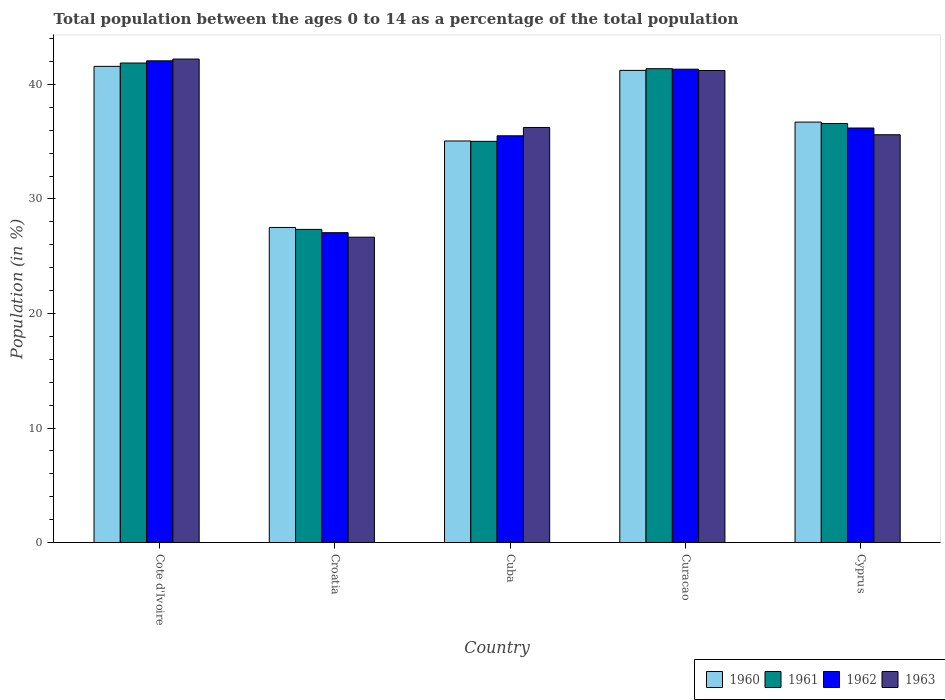How many groups of bars are there?
Your answer should be compact. 5. Are the number of bars per tick equal to the number of legend labels?
Keep it short and to the point. Yes. Are the number of bars on each tick of the X-axis equal?
Provide a succinct answer. Yes. How many bars are there on the 2nd tick from the left?
Your answer should be very brief. 4. What is the label of the 2nd group of bars from the left?
Offer a very short reply. Croatia. What is the percentage of the population ages 0 to 14 in 1963 in Cyprus?
Provide a short and direct response. 35.6. Across all countries, what is the maximum percentage of the population ages 0 to 14 in 1961?
Ensure brevity in your answer.  41.86. Across all countries, what is the minimum percentage of the population ages 0 to 14 in 1960?
Your response must be concise. 27.51. In which country was the percentage of the population ages 0 to 14 in 1961 maximum?
Provide a succinct answer. Cote d'Ivoire. In which country was the percentage of the population ages 0 to 14 in 1960 minimum?
Your answer should be compact. Croatia. What is the total percentage of the population ages 0 to 14 in 1961 in the graph?
Provide a succinct answer. 182.19. What is the difference between the percentage of the population ages 0 to 14 in 1961 in Croatia and that in Curacao?
Keep it short and to the point. -14.03. What is the difference between the percentage of the population ages 0 to 14 in 1962 in Croatia and the percentage of the population ages 0 to 14 in 1960 in Cote d'Ivoire?
Offer a very short reply. -14.52. What is the average percentage of the population ages 0 to 14 in 1960 per country?
Make the answer very short. 36.41. What is the difference between the percentage of the population ages 0 to 14 of/in 1963 and percentage of the population ages 0 to 14 of/in 1962 in Cyprus?
Keep it short and to the point. -0.59. What is the ratio of the percentage of the population ages 0 to 14 in 1962 in Croatia to that in Cyprus?
Your response must be concise. 0.75. Is the percentage of the population ages 0 to 14 in 1961 in Croatia less than that in Curacao?
Offer a terse response. Yes. What is the difference between the highest and the second highest percentage of the population ages 0 to 14 in 1962?
Offer a very short reply. -0.73. What is the difference between the highest and the lowest percentage of the population ages 0 to 14 in 1962?
Your response must be concise. 15. Is the sum of the percentage of the population ages 0 to 14 in 1963 in Curacao and Cyprus greater than the maximum percentage of the population ages 0 to 14 in 1962 across all countries?
Make the answer very short. Yes. Is it the case that in every country, the sum of the percentage of the population ages 0 to 14 in 1961 and percentage of the population ages 0 to 14 in 1960 is greater than the sum of percentage of the population ages 0 to 14 in 1962 and percentage of the population ages 0 to 14 in 1963?
Offer a very short reply. No. Is it the case that in every country, the sum of the percentage of the population ages 0 to 14 in 1963 and percentage of the population ages 0 to 14 in 1961 is greater than the percentage of the population ages 0 to 14 in 1962?
Your answer should be very brief. Yes. How many countries are there in the graph?
Offer a terse response. 5. What is the difference between two consecutive major ticks on the Y-axis?
Ensure brevity in your answer.  10. Are the values on the major ticks of Y-axis written in scientific E-notation?
Keep it short and to the point. No. Does the graph contain any zero values?
Keep it short and to the point. No. Does the graph contain grids?
Make the answer very short. No. How many legend labels are there?
Make the answer very short. 4. How are the legend labels stacked?
Give a very brief answer. Horizontal. What is the title of the graph?
Offer a terse response. Total population between the ages 0 to 14 as a percentage of the total population. What is the label or title of the X-axis?
Ensure brevity in your answer.  Country. What is the label or title of the Y-axis?
Offer a very short reply. Population (in %). What is the Population (in %) in 1960 in Cote d'Ivoire?
Give a very brief answer. 41.57. What is the Population (in %) in 1961 in Cote d'Ivoire?
Keep it short and to the point. 41.86. What is the Population (in %) of 1962 in Cote d'Ivoire?
Provide a succinct answer. 42.06. What is the Population (in %) in 1963 in Cote d'Ivoire?
Offer a terse response. 42.21. What is the Population (in %) in 1960 in Croatia?
Keep it short and to the point. 27.51. What is the Population (in %) of 1961 in Croatia?
Offer a terse response. 27.34. What is the Population (in %) of 1962 in Croatia?
Offer a terse response. 27.05. What is the Population (in %) in 1963 in Croatia?
Offer a very short reply. 26.66. What is the Population (in %) of 1960 in Cuba?
Provide a succinct answer. 35.06. What is the Population (in %) in 1961 in Cuba?
Offer a very short reply. 35.03. What is the Population (in %) in 1962 in Cuba?
Provide a succinct answer. 35.51. What is the Population (in %) in 1963 in Cuba?
Offer a very short reply. 36.24. What is the Population (in %) in 1960 in Curacao?
Keep it short and to the point. 41.22. What is the Population (in %) in 1961 in Curacao?
Your response must be concise. 41.37. What is the Population (in %) of 1962 in Curacao?
Your answer should be compact. 41.33. What is the Population (in %) in 1963 in Curacao?
Keep it short and to the point. 41.21. What is the Population (in %) of 1960 in Cyprus?
Offer a very short reply. 36.71. What is the Population (in %) of 1961 in Cyprus?
Ensure brevity in your answer.  36.59. What is the Population (in %) in 1962 in Cyprus?
Offer a very short reply. 36.19. What is the Population (in %) of 1963 in Cyprus?
Ensure brevity in your answer.  35.6. Across all countries, what is the maximum Population (in %) in 1960?
Provide a succinct answer. 41.57. Across all countries, what is the maximum Population (in %) in 1961?
Keep it short and to the point. 41.86. Across all countries, what is the maximum Population (in %) of 1962?
Provide a succinct answer. 42.06. Across all countries, what is the maximum Population (in %) in 1963?
Ensure brevity in your answer.  42.21. Across all countries, what is the minimum Population (in %) in 1960?
Provide a short and direct response. 27.51. Across all countries, what is the minimum Population (in %) of 1961?
Provide a succinct answer. 27.34. Across all countries, what is the minimum Population (in %) of 1962?
Provide a succinct answer. 27.05. Across all countries, what is the minimum Population (in %) of 1963?
Provide a succinct answer. 26.66. What is the total Population (in %) of 1960 in the graph?
Your answer should be compact. 182.07. What is the total Population (in %) in 1961 in the graph?
Your answer should be compact. 182.19. What is the total Population (in %) in 1962 in the graph?
Offer a very short reply. 182.14. What is the total Population (in %) of 1963 in the graph?
Your answer should be compact. 181.93. What is the difference between the Population (in %) in 1960 in Cote d'Ivoire and that in Croatia?
Offer a very short reply. 14.06. What is the difference between the Population (in %) of 1961 in Cote d'Ivoire and that in Croatia?
Your answer should be compact. 14.52. What is the difference between the Population (in %) of 1962 in Cote d'Ivoire and that in Croatia?
Give a very brief answer. 15. What is the difference between the Population (in %) in 1963 in Cote d'Ivoire and that in Croatia?
Your answer should be compact. 15.55. What is the difference between the Population (in %) of 1960 in Cote d'Ivoire and that in Cuba?
Give a very brief answer. 6.51. What is the difference between the Population (in %) of 1961 in Cote d'Ivoire and that in Cuba?
Provide a short and direct response. 6.84. What is the difference between the Population (in %) of 1962 in Cote d'Ivoire and that in Cuba?
Ensure brevity in your answer.  6.54. What is the difference between the Population (in %) in 1963 in Cote d'Ivoire and that in Cuba?
Offer a very short reply. 5.97. What is the difference between the Population (in %) in 1960 in Cote d'Ivoire and that in Curacao?
Keep it short and to the point. 0.35. What is the difference between the Population (in %) of 1961 in Cote d'Ivoire and that in Curacao?
Your answer should be compact. 0.49. What is the difference between the Population (in %) of 1962 in Cote d'Ivoire and that in Curacao?
Keep it short and to the point. 0.73. What is the difference between the Population (in %) of 1960 in Cote d'Ivoire and that in Cyprus?
Make the answer very short. 4.87. What is the difference between the Population (in %) of 1961 in Cote d'Ivoire and that in Cyprus?
Offer a very short reply. 5.28. What is the difference between the Population (in %) of 1962 in Cote d'Ivoire and that in Cyprus?
Make the answer very short. 5.87. What is the difference between the Population (in %) in 1963 in Cote d'Ivoire and that in Cyprus?
Your answer should be very brief. 6.61. What is the difference between the Population (in %) of 1960 in Croatia and that in Cuba?
Provide a short and direct response. -7.55. What is the difference between the Population (in %) of 1961 in Croatia and that in Cuba?
Provide a succinct answer. -7.69. What is the difference between the Population (in %) in 1962 in Croatia and that in Cuba?
Your answer should be compact. -8.46. What is the difference between the Population (in %) of 1963 in Croatia and that in Cuba?
Offer a very short reply. -9.58. What is the difference between the Population (in %) in 1960 in Croatia and that in Curacao?
Offer a terse response. -13.71. What is the difference between the Population (in %) in 1961 in Croatia and that in Curacao?
Your answer should be compact. -14.03. What is the difference between the Population (in %) in 1962 in Croatia and that in Curacao?
Give a very brief answer. -14.27. What is the difference between the Population (in %) of 1963 in Croatia and that in Curacao?
Offer a terse response. -14.55. What is the difference between the Population (in %) of 1960 in Croatia and that in Cyprus?
Your response must be concise. -9.2. What is the difference between the Population (in %) in 1961 in Croatia and that in Cyprus?
Your response must be concise. -9.25. What is the difference between the Population (in %) in 1962 in Croatia and that in Cyprus?
Ensure brevity in your answer.  -9.14. What is the difference between the Population (in %) of 1963 in Croatia and that in Cyprus?
Offer a terse response. -8.94. What is the difference between the Population (in %) of 1960 in Cuba and that in Curacao?
Provide a succinct answer. -6.16. What is the difference between the Population (in %) of 1961 in Cuba and that in Curacao?
Provide a short and direct response. -6.34. What is the difference between the Population (in %) of 1962 in Cuba and that in Curacao?
Your answer should be very brief. -5.82. What is the difference between the Population (in %) of 1963 in Cuba and that in Curacao?
Your response must be concise. -4.97. What is the difference between the Population (in %) of 1960 in Cuba and that in Cyprus?
Your response must be concise. -1.65. What is the difference between the Population (in %) in 1961 in Cuba and that in Cyprus?
Your answer should be very brief. -1.56. What is the difference between the Population (in %) in 1962 in Cuba and that in Cyprus?
Offer a very short reply. -0.68. What is the difference between the Population (in %) of 1963 in Cuba and that in Cyprus?
Provide a short and direct response. 0.63. What is the difference between the Population (in %) in 1960 in Curacao and that in Cyprus?
Make the answer very short. 4.52. What is the difference between the Population (in %) in 1961 in Curacao and that in Cyprus?
Ensure brevity in your answer.  4.78. What is the difference between the Population (in %) of 1962 in Curacao and that in Cyprus?
Give a very brief answer. 5.14. What is the difference between the Population (in %) in 1963 in Curacao and that in Cyprus?
Your answer should be very brief. 5.61. What is the difference between the Population (in %) of 1960 in Cote d'Ivoire and the Population (in %) of 1961 in Croatia?
Ensure brevity in your answer.  14.23. What is the difference between the Population (in %) in 1960 in Cote d'Ivoire and the Population (in %) in 1962 in Croatia?
Provide a succinct answer. 14.52. What is the difference between the Population (in %) of 1960 in Cote d'Ivoire and the Population (in %) of 1963 in Croatia?
Make the answer very short. 14.91. What is the difference between the Population (in %) of 1961 in Cote d'Ivoire and the Population (in %) of 1962 in Croatia?
Your response must be concise. 14.81. What is the difference between the Population (in %) of 1961 in Cote d'Ivoire and the Population (in %) of 1963 in Croatia?
Ensure brevity in your answer.  15.2. What is the difference between the Population (in %) in 1962 in Cote d'Ivoire and the Population (in %) in 1963 in Croatia?
Offer a very short reply. 15.4. What is the difference between the Population (in %) of 1960 in Cote d'Ivoire and the Population (in %) of 1961 in Cuba?
Your answer should be compact. 6.54. What is the difference between the Population (in %) of 1960 in Cote d'Ivoire and the Population (in %) of 1962 in Cuba?
Offer a terse response. 6.06. What is the difference between the Population (in %) in 1960 in Cote d'Ivoire and the Population (in %) in 1963 in Cuba?
Provide a short and direct response. 5.33. What is the difference between the Population (in %) in 1961 in Cote d'Ivoire and the Population (in %) in 1962 in Cuba?
Offer a terse response. 6.35. What is the difference between the Population (in %) in 1961 in Cote d'Ivoire and the Population (in %) in 1963 in Cuba?
Provide a succinct answer. 5.63. What is the difference between the Population (in %) of 1962 in Cote d'Ivoire and the Population (in %) of 1963 in Cuba?
Provide a succinct answer. 5.82. What is the difference between the Population (in %) in 1960 in Cote d'Ivoire and the Population (in %) in 1961 in Curacao?
Provide a short and direct response. 0.2. What is the difference between the Population (in %) in 1960 in Cote d'Ivoire and the Population (in %) in 1962 in Curacao?
Keep it short and to the point. 0.24. What is the difference between the Population (in %) in 1960 in Cote d'Ivoire and the Population (in %) in 1963 in Curacao?
Provide a short and direct response. 0.36. What is the difference between the Population (in %) in 1961 in Cote d'Ivoire and the Population (in %) in 1962 in Curacao?
Your answer should be very brief. 0.54. What is the difference between the Population (in %) of 1961 in Cote d'Ivoire and the Population (in %) of 1963 in Curacao?
Keep it short and to the point. 0.65. What is the difference between the Population (in %) of 1962 in Cote d'Ivoire and the Population (in %) of 1963 in Curacao?
Make the answer very short. 0.84. What is the difference between the Population (in %) in 1960 in Cote d'Ivoire and the Population (in %) in 1961 in Cyprus?
Make the answer very short. 4.99. What is the difference between the Population (in %) of 1960 in Cote d'Ivoire and the Population (in %) of 1962 in Cyprus?
Provide a succinct answer. 5.38. What is the difference between the Population (in %) in 1960 in Cote d'Ivoire and the Population (in %) in 1963 in Cyprus?
Keep it short and to the point. 5.97. What is the difference between the Population (in %) of 1961 in Cote d'Ivoire and the Population (in %) of 1962 in Cyprus?
Keep it short and to the point. 5.67. What is the difference between the Population (in %) in 1961 in Cote d'Ivoire and the Population (in %) in 1963 in Cyprus?
Ensure brevity in your answer.  6.26. What is the difference between the Population (in %) in 1962 in Cote d'Ivoire and the Population (in %) in 1963 in Cyprus?
Keep it short and to the point. 6.45. What is the difference between the Population (in %) of 1960 in Croatia and the Population (in %) of 1961 in Cuba?
Provide a succinct answer. -7.52. What is the difference between the Population (in %) of 1960 in Croatia and the Population (in %) of 1962 in Cuba?
Ensure brevity in your answer.  -8. What is the difference between the Population (in %) in 1960 in Croatia and the Population (in %) in 1963 in Cuba?
Your response must be concise. -8.73. What is the difference between the Population (in %) in 1961 in Croatia and the Population (in %) in 1962 in Cuba?
Your answer should be compact. -8.17. What is the difference between the Population (in %) in 1961 in Croatia and the Population (in %) in 1963 in Cuba?
Offer a terse response. -8.9. What is the difference between the Population (in %) in 1962 in Croatia and the Population (in %) in 1963 in Cuba?
Make the answer very short. -9.18. What is the difference between the Population (in %) in 1960 in Croatia and the Population (in %) in 1961 in Curacao?
Give a very brief answer. -13.86. What is the difference between the Population (in %) of 1960 in Croatia and the Population (in %) of 1962 in Curacao?
Your answer should be compact. -13.82. What is the difference between the Population (in %) of 1960 in Croatia and the Population (in %) of 1963 in Curacao?
Offer a terse response. -13.7. What is the difference between the Population (in %) of 1961 in Croatia and the Population (in %) of 1962 in Curacao?
Provide a succinct answer. -13.99. What is the difference between the Population (in %) in 1961 in Croatia and the Population (in %) in 1963 in Curacao?
Make the answer very short. -13.87. What is the difference between the Population (in %) of 1962 in Croatia and the Population (in %) of 1963 in Curacao?
Your answer should be very brief. -14.16. What is the difference between the Population (in %) of 1960 in Croatia and the Population (in %) of 1961 in Cyprus?
Offer a terse response. -9.08. What is the difference between the Population (in %) of 1960 in Croatia and the Population (in %) of 1962 in Cyprus?
Offer a terse response. -8.68. What is the difference between the Population (in %) of 1960 in Croatia and the Population (in %) of 1963 in Cyprus?
Your response must be concise. -8.09. What is the difference between the Population (in %) in 1961 in Croatia and the Population (in %) in 1962 in Cyprus?
Your answer should be very brief. -8.85. What is the difference between the Population (in %) of 1961 in Croatia and the Population (in %) of 1963 in Cyprus?
Provide a succinct answer. -8.26. What is the difference between the Population (in %) in 1962 in Croatia and the Population (in %) in 1963 in Cyprus?
Your answer should be compact. -8.55. What is the difference between the Population (in %) of 1960 in Cuba and the Population (in %) of 1961 in Curacao?
Give a very brief answer. -6.31. What is the difference between the Population (in %) of 1960 in Cuba and the Population (in %) of 1962 in Curacao?
Your answer should be very brief. -6.27. What is the difference between the Population (in %) of 1960 in Cuba and the Population (in %) of 1963 in Curacao?
Keep it short and to the point. -6.15. What is the difference between the Population (in %) in 1961 in Cuba and the Population (in %) in 1962 in Curacao?
Ensure brevity in your answer.  -6.3. What is the difference between the Population (in %) of 1961 in Cuba and the Population (in %) of 1963 in Curacao?
Your answer should be compact. -6.18. What is the difference between the Population (in %) of 1962 in Cuba and the Population (in %) of 1963 in Curacao?
Provide a succinct answer. -5.7. What is the difference between the Population (in %) in 1960 in Cuba and the Population (in %) in 1961 in Cyprus?
Your response must be concise. -1.53. What is the difference between the Population (in %) in 1960 in Cuba and the Population (in %) in 1962 in Cyprus?
Provide a succinct answer. -1.13. What is the difference between the Population (in %) in 1960 in Cuba and the Population (in %) in 1963 in Cyprus?
Give a very brief answer. -0.54. What is the difference between the Population (in %) of 1961 in Cuba and the Population (in %) of 1962 in Cyprus?
Keep it short and to the point. -1.16. What is the difference between the Population (in %) in 1961 in Cuba and the Population (in %) in 1963 in Cyprus?
Your answer should be compact. -0.58. What is the difference between the Population (in %) of 1962 in Cuba and the Population (in %) of 1963 in Cyprus?
Give a very brief answer. -0.09. What is the difference between the Population (in %) of 1960 in Curacao and the Population (in %) of 1961 in Cyprus?
Your answer should be very brief. 4.64. What is the difference between the Population (in %) in 1960 in Curacao and the Population (in %) in 1962 in Cyprus?
Provide a short and direct response. 5.03. What is the difference between the Population (in %) of 1960 in Curacao and the Population (in %) of 1963 in Cyprus?
Make the answer very short. 5.62. What is the difference between the Population (in %) in 1961 in Curacao and the Population (in %) in 1962 in Cyprus?
Ensure brevity in your answer.  5.18. What is the difference between the Population (in %) in 1961 in Curacao and the Population (in %) in 1963 in Cyprus?
Provide a short and direct response. 5.77. What is the difference between the Population (in %) of 1962 in Curacao and the Population (in %) of 1963 in Cyprus?
Ensure brevity in your answer.  5.72. What is the average Population (in %) of 1960 per country?
Offer a very short reply. 36.41. What is the average Population (in %) of 1961 per country?
Ensure brevity in your answer.  36.44. What is the average Population (in %) of 1962 per country?
Provide a short and direct response. 36.43. What is the average Population (in %) of 1963 per country?
Your answer should be compact. 36.39. What is the difference between the Population (in %) of 1960 and Population (in %) of 1961 in Cote d'Ivoire?
Your response must be concise. -0.29. What is the difference between the Population (in %) in 1960 and Population (in %) in 1962 in Cote d'Ivoire?
Offer a terse response. -0.48. What is the difference between the Population (in %) in 1960 and Population (in %) in 1963 in Cote d'Ivoire?
Your answer should be compact. -0.64. What is the difference between the Population (in %) in 1961 and Population (in %) in 1962 in Cote d'Ivoire?
Provide a succinct answer. -0.19. What is the difference between the Population (in %) of 1961 and Population (in %) of 1963 in Cote d'Ivoire?
Offer a terse response. -0.35. What is the difference between the Population (in %) of 1962 and Population (in %) of 1963 in Cote d'Ivoire?
Your response must be concise. -0.15. What is the difference between the Population (in %) in 1960 and Population (in %) in 1961 in Croatia?
Make the answer very short. 0.17. What is the difference between the Population (in %) in 1960 and Population (in %) in 1962 in Croatia?
Provide a short and direct response. 0.46. What is the difference between the Population (in %) of 1960 and Population (in %) of 1963 in Croatia?
Ensure brevity in your answer.  0.85. What is the difference between the Population (in %) of 1961 and Population (in %) of 1962 in Croatia?
Your answer should be very brief. 0.29. What is the difference between the Population (in %) of 1961 and Population (in %) of 1963 in Croatia?
Give a very brief answer. 0.68. What is the difference between the Population (in %) in 1962 and Population (in %) in 1963 in Croatia?
Keep it short and to the point. 0.39. What is the difference between the Population (in %) in 1960 and Population (in %) in 1961 in Cuba?
Ensure brevity in your answer.  0.03. What is the difference between the Population (in %) in 1960 and Population (in %) in 1962 in Cuba?
Make the answer very short. -0.45. What is the difference between the Population (in %) in 1960 and Population (in %) in 1963 in Cuba?
Offer a very short reply. -1.18. What is the difference between the Population (in %) of 1961 and Population (in %) of 1962 in Cuba?
Provide a succinct answer. -0.48. What is the difference between the Population (in %) in 1961 and Population (in %) in 1963 in Cuba?
Provide a short and direct response. -1.21. What is the difference between the Population (in %) of 1962 and Population (in %) of 1963 in Cuba?
Keep it short and to the point. -0.73. What is the difference between the Population (in %) in 1960 and Population (in %) in 1961 in Curacao?
Your answer should be very brief. -0.15. What is the difference between the Population (in %) of 1960 and Population (in %) of 1962 in Curacao?
Your response must be concise. -0.11. What is the difference between the Population (in %) of 1960 and Population (in %) of 1963 in Curacao?
Provide a succinct answer. 0.01. What is the difference between the Population (in %) in 1961 and Population (in %) in 1962 in Curacao?
Provide a short and direct response. 0.04. What is the difference between the Population (in %) in 1961 and Population (in %) in 1963 in Curacao?
Offer a terse response. 0.16. What is the difference between the Population (in %) of 1962 and Population (in %) of 1963 in Curacao?
Ensure brevity in your answer.  0.12. What is the difference between the Population (in %) in 1960 and Population (in %) in 1961 in Cyprus?
Offer a terse response. 0.12. What is the difference between the Population (in %) of 1960 and Population (in %) of 1962 in Cyprus?
Ensure brevity in your answer.  0.52. What is the difference between the Population (in %) in 1960 and Population (in %) in 1963 in Cyprus?
Keep it short and to the point. 1.1. What is the difference between the Population (in %) of 1961 and Population (in %) of 1962 in Cyprus?
Offer a very short reply. 0.4. What is the difference between the Population (in %) in 1961 and Population (in %) in 1963 in Cyprus?
Keep it short and to the point. 0.98. What is the difference between the Population (in %) in 1962 and Population (in %) in 1963 in Cyprus?
Give a very brief answer. 0.59. What is the ratio of the Population (in %) of 1960 in Cote d'Ivoire to that in Croatia?
Provide a short and direct response. 1.51. What is the ratio of the Population (in %) of 1961 in Cote d'Ivoire to that in Croatia?
Ensure brevity in your answer.  1.53. What is the ratio of the Population (in %) in 1962 in Cote d'Ivoire to that in Croatia?
Keep it short and to the point. 1.55. What is the ratio of the Population (in %) in 1963 in Cote d'Ivoire to that in Croatia?
Keep it short and to the point. 1.58. What is the ratio of the Population (in %) in 1960 in Cote d'Ivoire to that in Cuba?
Offer a very short reply. 1.19. What is the ratio of the Population (in %) in 1961 in Cote d'Ivoire to that in Cuba?
Offer a terse response. 1.2. What is the ratio of the Population (in %) of 1962 in Cote d'Ivoire to that in Cuba?
Provide a succinct answer. 1.18. What is the ratio of the Population (in %) in 1963 in Cote d'Ivoire to that in Cuba?
Provide a short and direct response. 1.16. What is the ratio of the Population (in %) of 1960 in Cote d'Ivoire to that in Curacao?
Offer a terse response. 1.01. What is the ratio of the Population (in %) in 1962 in Cote d'Ivoire to that in Curacao?
Ensure brevity in your answer.  1.02. What is the ratio of the Population (in %) in 1963 in Cote d'Ivoire to that in Curacao?
Make the answer very short. 1.02. What is the ratio of the Population (in %) of 1960 in Cote d'Ivoire to that in Cyprus?
Your answer should be very brief. 1.13. What is the ratio of the Population (in %) in 1961 in Cote d'Ivoire to that in Cyprus?
Give a very brief answer. 1.14. What is the ratio of the Population (in %) of 1962 in Cote d'Ivoire to that in Cyprus?
Give a very brief answer. 1.16. What is the ratio of the Population (in %) in 1963 in Cote d'Ivoire to that in Cyprus?
Give a very brief answer. 1.19. What is the ratio of the Population (in %) in 1960 in Croatia to that in Cuba?
Keep it short and to the point. 0.78. What is the ratio of the Population (in %) of 1961 in Croatia to that in Cuba?
Provide a succinct answer. 0.78. What is the ratio of the Population (in %) in 1962 in Croatia to that in Cuba?
Keep it short and to the point. 0.76. What is the ratio of the Population (in %) in 1963 in Croatia to that in Cuba?
Your answer should be very brief. 0.74. What is the ratio of the Population (in %) in 1960 in Croatia to that in Curacao?
Provide a short and direct response. 0.67. What is the ratio of the Population (in %) of 1961 in Croatia to that in Curacao?
Keep it short and to the point. 0.66. What is the ratio of the Population (in %) of 1962 in Croatia to that in Curacao?
Keep it short and to the point. 0.65. What is the ratio of the Population (in %) in 1963 in Croatia to that in Curacao?
Your answer should be compact. 0.65. What is the ratio of the Population (in %) in 1960 in Croatia to that in Cyprus?
Offer a very short reply. 0.75. What is the ratio of the Population (in %) of 1961 in Croatia to that in Cyprus?
Your response must be concise. 0.75. What is the ratio of the Population (in %) in 1962 in Croatia to that in Cyprus?
Your answer should be compact. 0.75. What is the ratio of the Population (in %) of 1963 in Croatia to that in Cyprus?
Give a very brief answer. 0.75. What is the ratio of the Population (in %) in 1960 in Cuba to that in Curacao?
Offer a very short reply. 0.85. What is the ratio of the Population (in %) in 1961 in Cuba to that in Curacao?
Provide a succinct answer. 0.85. What is the ratio of the Population (in %) of 1962 in Cuba to that in Curacao?
Keep it short and to the point. 0.86. What is the ratio of the Population (in %) of 1963 in Cuba to that in Curacao?
Offer a terse response. 0.88. What is the ratio of the Population (in %) in 1960 in Cuba to that in Cyprus?
Keep it short and to the point. 0.96. What is the ratio of the Population (in %) of 1961 in Cuba to that in Cyprus?
Offer a terse response. 0.96. What is the ratio of the Population (in %) in 1962 in Cuba to that in Cyprus?
Provide a short and direct response. 0.98. What is the ratio of the Population (in %) in 1963 in Cuba to that in Cyprus?
Provide a succinct answer. 1.02. What is the ratio of the Population (in %) of 1960 in Curacao to that in Cyprus?
Offer a terse response. 1.12. What is the ratio of the Population (in %) in 1961 in Curacao to that in Cyprus?
Provide a short and direct response. 1.13. What is the ratio of the Population (in %) in 1962 in Curacao to that in Cyprus?
Provide a succinct answer. 1.14. What is the ratio of the Population (in %) in 1963 in Curacao to that in Cyprus?
Your answer should be compact. 1.16. What is the difference between the highest and the second highest Population (in %) in 1960?
Offer a very short reply. 0.35. What is the difference between the highest and the second highest Population (in %) of 1961?
Provide a succinct answer. 0.49. What is the difference between the highest and the second highest Population (in %) of 1962?
Give a very brief answer. 0.73. What is the difference between the highest and the lowest Population (in %) of 1960?
Offer a very short reply. 14.06. What is the difference between the highest and the lowest Population (in %) of 1961?
Give a very brief answer. 14.52. What is the difference between the highest and the lowest Population (in %) of 1962?
Ensure brevity in your answer.  15. What is the difference between the highest and the lowest Population (in %) of 1963?
Make the answer very short. 15.55. 